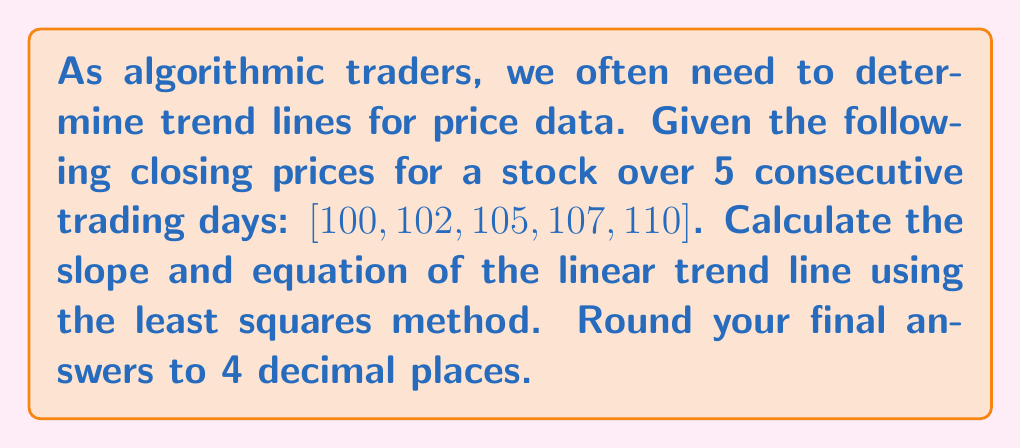Teach me how to tackle this problem. To find the slope and equation of the trend line using the least squares method, we'll follow these steps:

1) Let $x$ represent the day number (1 to 5) and $y$ represent the closing price.

2) Calculate the following sums:
   $\sum x = 1 + 2 + 3 + 4 + 5 = 15$
   $\sum y = 100 + 102 + 105 + 107 + 110 = 524$
   $\sum xy = (1)(100) + (2)(102) + (3)(105) + (4)(107) + (5)(110) = 1,615$
   $\sum x^2 = 1^2 + 2^2 + 3^2 + 4^2 + 5^2 = 55$

3) Use the slope formula:
   $$m = \frac{n\sum xy - \sum x \sum y}{n\sum x^2 - (\sum x)^2}$$
   where $n$ is the number of data points (5 in this case).

4) Substitute the values:
   $$m = \frac{5(1,615) - (15)(524)}{5(55) - (15)^2} = \frac{8,075 - 7,860}{275 - 225} = \frac{215}{50} = 2.5$$

5) Calculate the y-intercept using $\bar{x}$ and $\bar{y}$:
   $\bar{x} = \frac{\sum x}{n} = \frac{15}{5} = 3$
   $\bar{y} = \frac{\sum y}{n} = \frac{524}{5} = 104.8$

   $$b = \bar{y} - m\bar{x} = 104.8 - (2.5)(3) = 97.3$$

6) The equation of the trend line is:
   $$y = mx + b = 2.5x + 97.3$$
Answer: Slope: $m = 2.5000$
Equation of trend line: $y = 2.5000x + 97.3000$ 